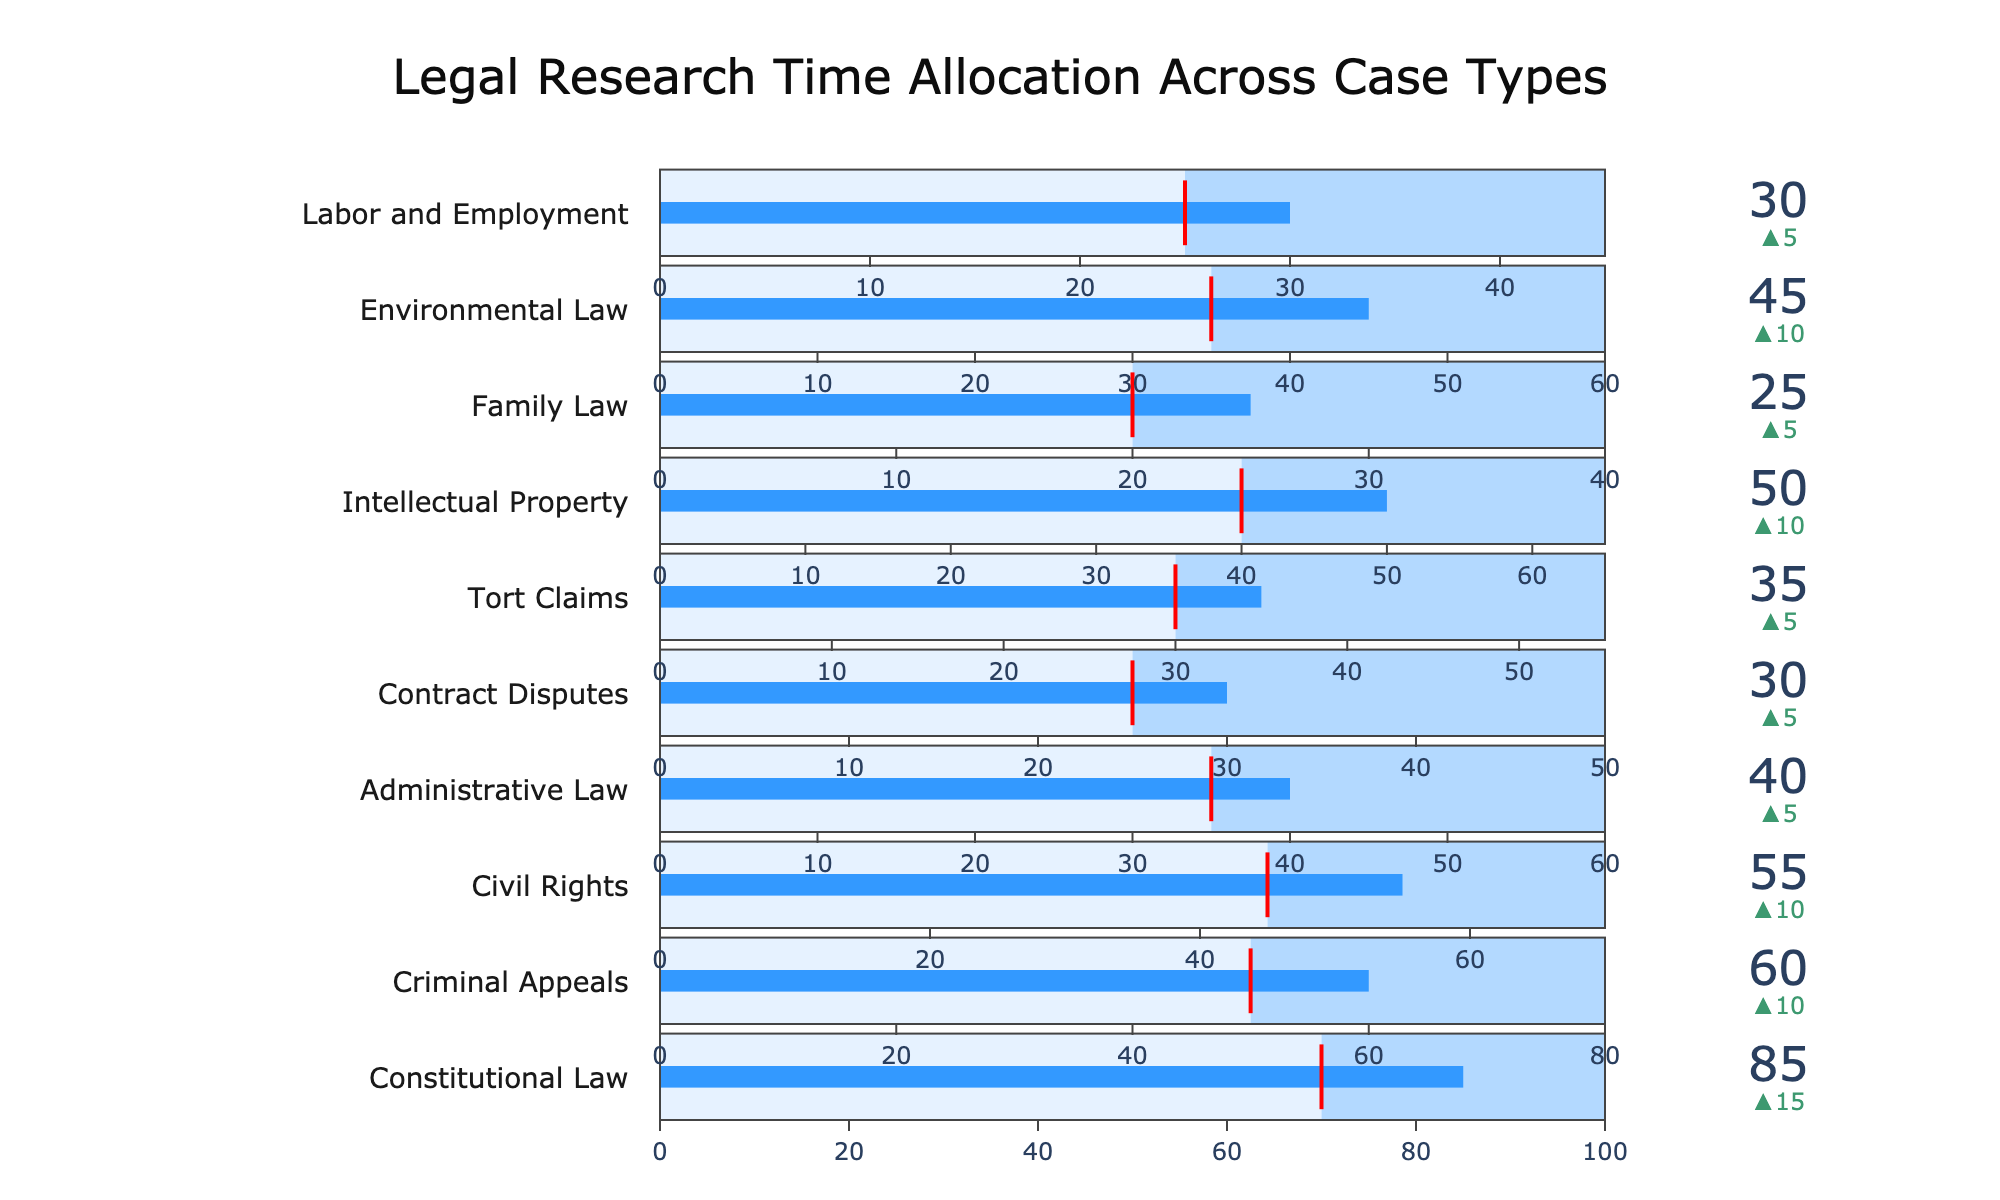What's the total number of case types presented? We count each unique case type listed on the chart. There are ten case types displayed.
Answer: 10 What is the title of the figure? The title summarizes the main subject of the chart. The title displayed on the chart reads "Legal Research Time Allocation Across Case Types."
Answer: Legal Research Time Allocation Across Case Types Which case type has the highest actual research time? To determine this, we look for the bullet that goes the furthest to the right. "Constitutional Law" has an actual research time of 85 hours, which is the highest.
Answer: Constitutional Law What is the difference between the actual and target hours for Criminal Appeals? The actual hours for Criminal Appeals are 60, and the target hours are 50. The difference is 60 - 50, which equals 10 hours.
Answer: 10 How many case types have a maximum research time of 60 hours? We count all the case types where the maximum research time reaches 60 hours. These are Administrative Law and Environmental Law, totaling two case types.
Answer: 2 Is the actual research time for Contract Disputes above, below, or at the target hours? We compare the actual hours (30) against the target hours (25). Since 30 is greater than 25, it is above the target hours.
Answer: Above Which case type has the lowest target research time? We find the case type with the smallest target value. "Family Law" has the lowest target hours at 20 hours.
Answer: Family Law Compare the actual research time for Environmental Law and Civil Rights. Which one has more hours and by how much? Environmental Law has 45 hours, and Civil Rights has 55 hours. Civil Rights exceeds Environmental Law by 55 - 45 = 10 hours.
Answer: Civil Rights by 10 Which case type's actual research time matches its target hours most closely? We compare the differences between actual and target hours for all case types. Administrative Law has a difference of only 5 hours (Actual: 40, Target: 35), the smallest discrepancy.
Answer: Administrative Law What color represents the threshold in the bullet chart? The threshold is highlighted with a specific visual element to indicate the target hours. In this chart, the threshold is marked by a red line.
Answer: Red 